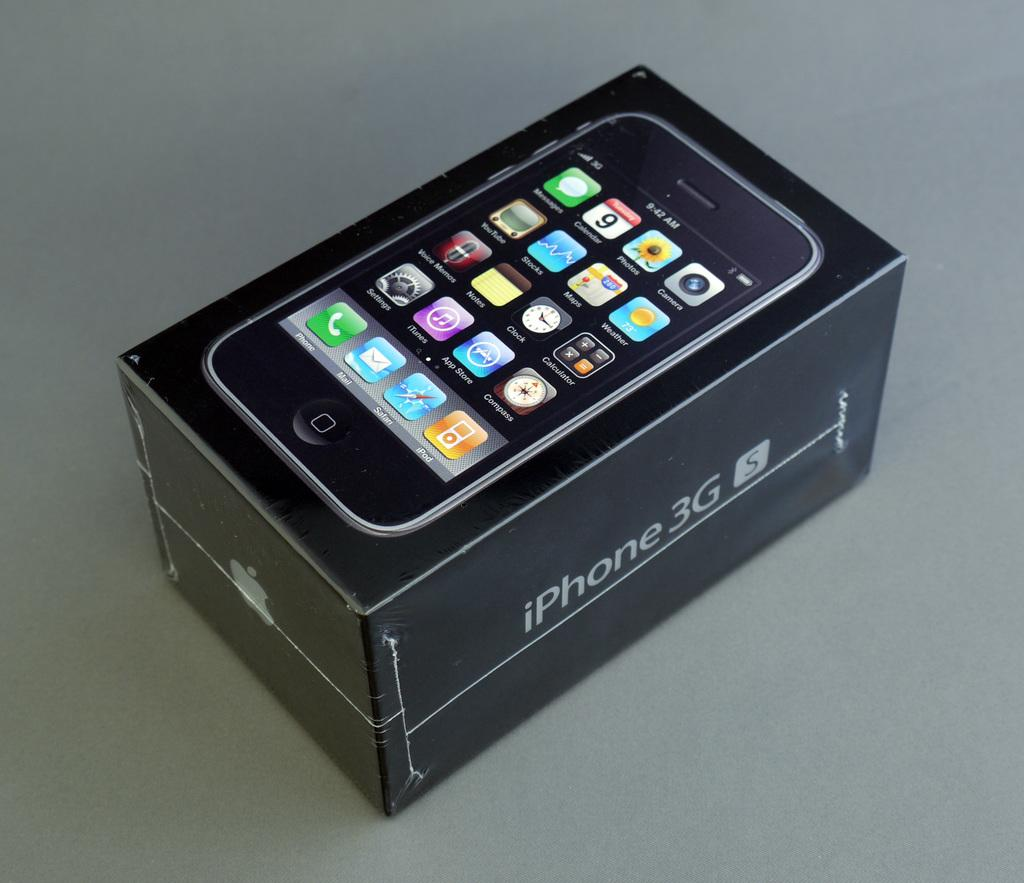<image>
Offer a succinct explanation of the picture presented. the word iPhone that is on a case 